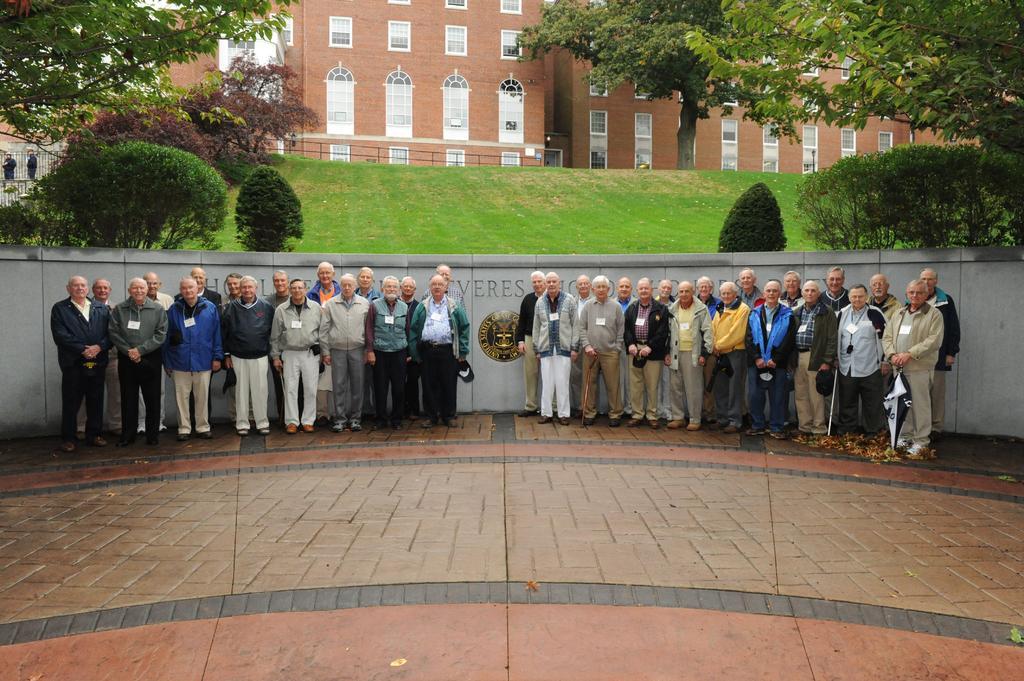Please provide a concise description of this image. This image consists of many persons standing and they are wearing ID cards. At the bottom, there is a floor. In the background, we can see the trees and green grass. And there is a building along with the windows. 